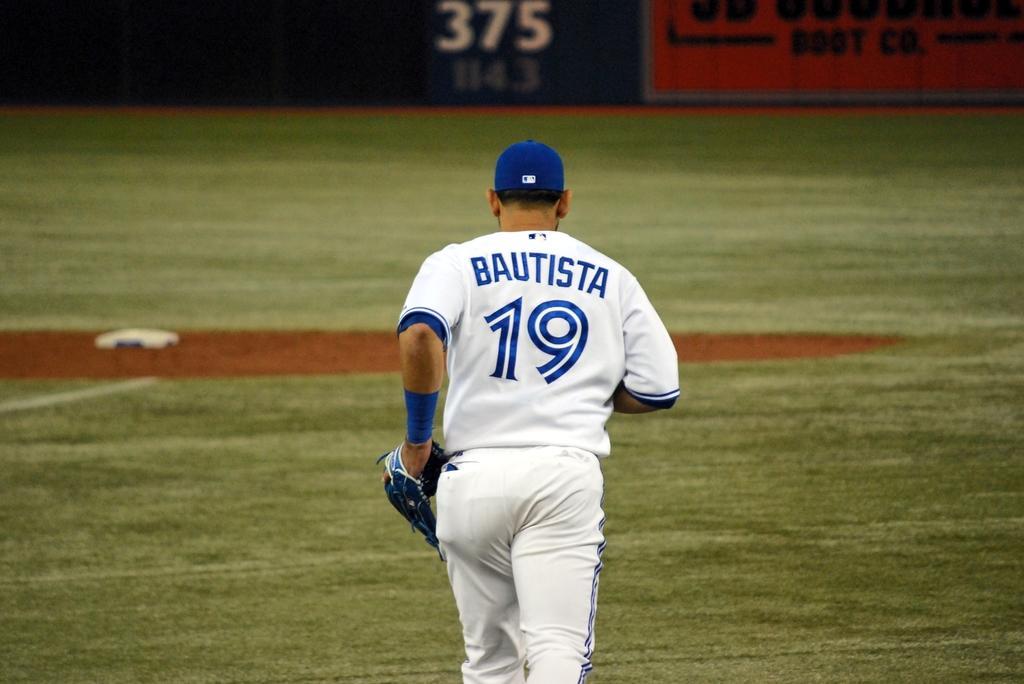Could you give a brief overview of what you see in this image? In this picture there is a person running and wore a cap and glove and we can see grass. In the background of the image we can see hoardings. 